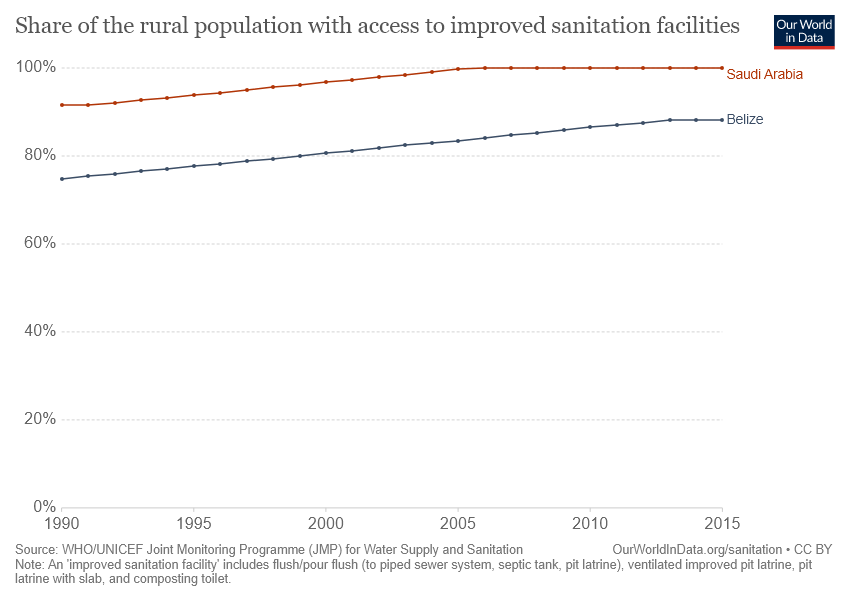Give some essential details in this illustration. The red graph line represents Saudi Arabia. It took Saudi Arabia 15 years to reach its highest point of 100%. 